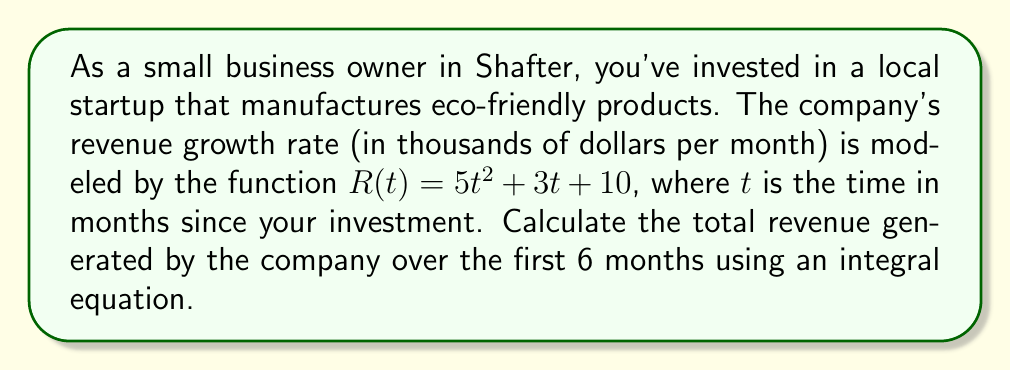Can you solve this math problem? To calculate the total revenue over time, we need to integrate the revenue growth rate function $R(t)$ over the given time period. Here's how we solve this problem:

1. Set up the integral equation:
   $$\text{Total Revenue} = \int_0^6 R(t) dt = \int_0^6 (5t^2 + 3t + 10) dt$$

2. Integrate the function:
   $$\int_0^6 (5t^2 + 3t + 10) dt = \left[\frac{5t^3}{3} + \frac{3t^2}{2} + 10t\right]_0^6$$

3. Evaluate the integral:
   $$\left[\frac{5(6^3)}{3} + \frac{3(6^2)}{2} + 10(6)\right] - \left[\frac{5(0^3)}{3} + \frac{3(0^2)}{2} + 10(0)\right]$$

4. Simplify:
   $$\left[360 + 54 + 60\right] - [0] = 474$$

5. The result is in thousands of dollars, so we need to multiply by 1000:
   $$474 \times 1000 = 474,000$$

Therefore, the total revenue generated over the first 6 months is $474,000.
Answer: $474,000 